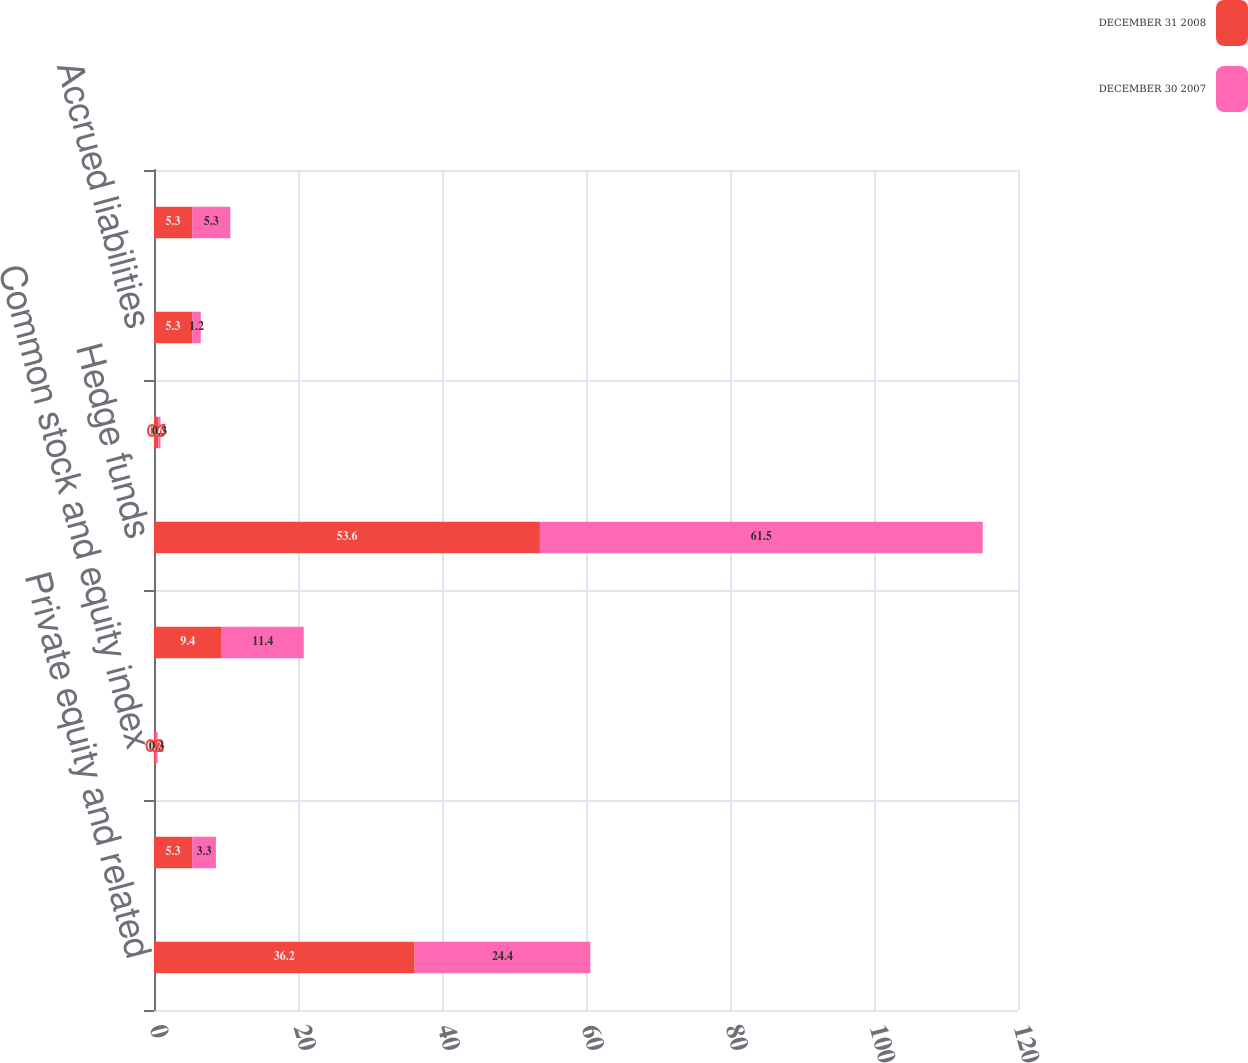Convert chart to OTSL. <chart><loc_0><loc_0><loc_500><loc_500><stacked_bar_chart><ecel><fcel>Private equity and related<fcel>Real estate and related funds<fcel>Common stock and equity index<fcel>Fixed income<fcel>Hedge funds<fcel>Net receivables<fcel>Accrued liabilities<fcel>Total<nl><fcel>DECEMBER 31 2008<fcel>36.2<fcel>5.3<fcel>0.2<fcel>9.4<fcel>53.6<fcel>0.6<fcel>5.3<fcel>5.3<nl><fcel>DECEMBER 30 2007<fcel>24.4<fcel>3.3<fcel>0.3<fcel>11.4<fcel>61.5<fcel>0.3<fcel>1.2<fcel>5.3<nl></chart> 